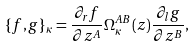Convert formula to latex. <formula><loc_0><loc_0><loc_500><loc_500>\{ f , g \} _ { \kappa } = \frac { \partial _ { r } f } { \partial z ^ { A } } \Omega ^ { A B } _ { \kappa } ( z ) \frac { \partial _ { l } g } { \partial z ^ { B } } ,</formula> 